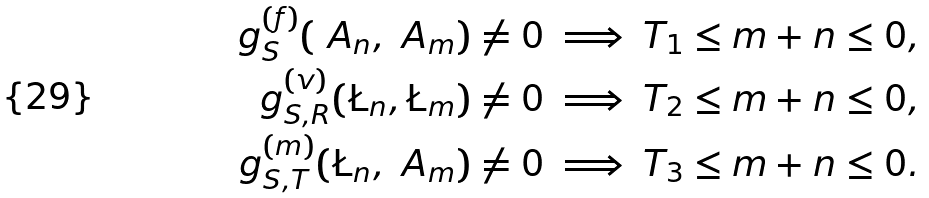<formula> <loc_0><loc_0><loc_500><loc_500>\ g _ { S } ^ { ( f ) } ( \ A _ { n } , \ A _ { m } ) \ne 0 & \implies T _ { 1 } \leq m + n \leq 0 , \\ \ g _ { S , R } ^ { ( v ) } ( \L _ { n } , \L _ { m } ) \ne 0 & \implies T _ { 2 } \leq m + n \leq 0 , \\ \ g _ { S , T } ^ { ( m ) } ( \L _ { n } , \ A _ { m } ) \ne 0 & \implies T _ { 3 } \leq m + n \leq 0 .</formula> 